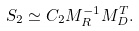<formula> <loc_0><loc_0><loc_500><loc_500>S _ { 2 } \simeq C _ { 2 } M _ { R } ^ { - 1 } M _ { D } ^ { T } .</formula> 